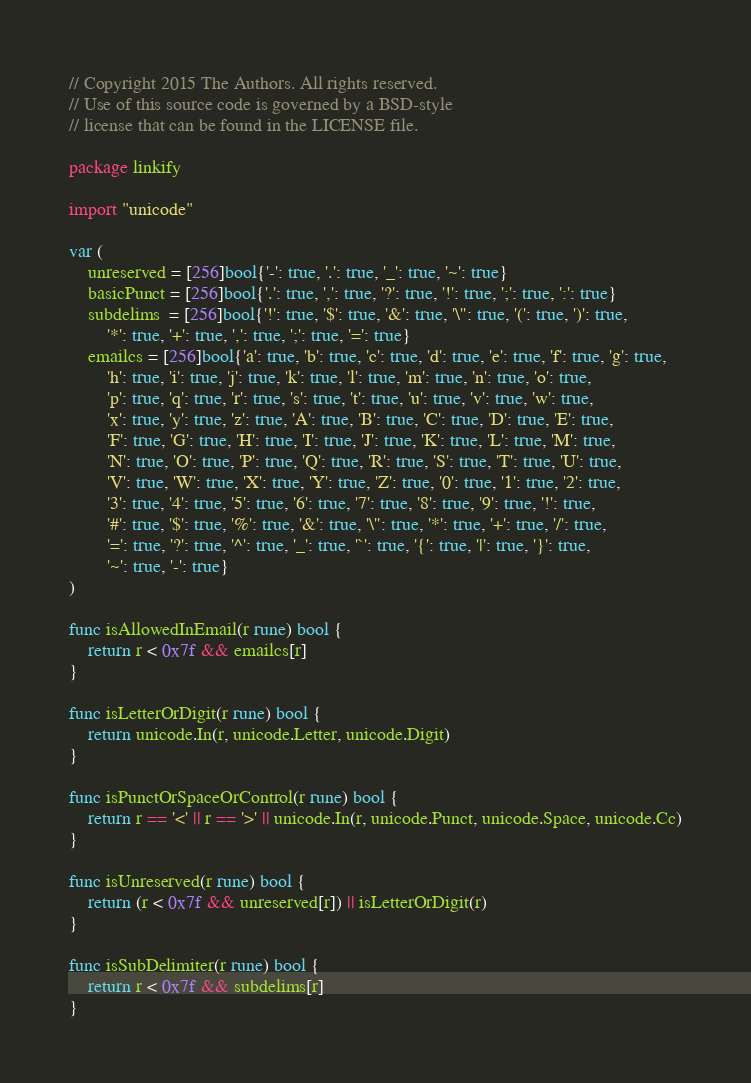Convert code to text. <code><loc_0><loc_0><loc_500><loc_500><_Go_>// Copyright 2015 The Authors. All rights reserved.
// Use of this source code is governed by a BSD-style
// license that can be found in the LICENSE file.

package linkify

import "unicode"

var (
	unreserved = [256]bool{'-': true, '.': true, '_': true, '~': true}
	basicPunct = [256]bool{'.': true, ',': true, '?': true, '!': true, ';': true, ':': true}
	subdelims  = [256]bool{'!': true, '$': true, '&': true, '\'': true, '(': true, ')': true,
		'*': true, '+': true, ',': true, ';': true, '=': true}
	emailcs = [256]bool{'a': true, 'b': true, 'c': true, 'd': true, 'e': true, 'f': true, 'g': true,
		'h': true, 'i': true, 'j': true, 'k': true, 'l': true, 'm': true, 'n': true, 'o': true,
		'p': true, 'q': true, 'r': true, 's': true, 't': true, 'u': true, 'v': true, 'w': true,
		'x': true, 'y': true, 'z': true, 'A': true, 'B': true, 'C': true, 'D': true, 'E': true,
		'F': true, 'G': true, 'H': true, 'I': true, 'J': true, 'K': true, 'L': true, 'M': true,
		'N': true, 'O': true, 'P': true, 'Q': true, 'R': true, 'S': true, 'T': true, 'U': true,
		'V': true, 'W': true, 'X': true, 'Y': true, 'Z': true, '0': true, '1': true, '2': true,
		'3': true, '4': true, '5': true, '6': true, '7': true, '8': true, '9': true, '!': true,
		'#': true, '$': true, '%': true, '&': true, '\'': true, '*': true, '+': true, '/': true,
		'=': true, '?': true, '^': true, '_': true, '`': true, '{': true, '|': true, '}': true,
		'~': true, '-': true}
)

func isAllowedInEmail(r rune) bool {
	return r < 0x7f && emailcs[r]
}

func isLetterOrDigit(r rune) bool {
	return unicode.In(r, unicode.Letter, unicode.Digit)
}

func isPunctOrSpaceOrControl(r rune) bool {
	return r == '<' || r == '>' || unicode.In(r, unicode.Punct, unicode.Space, unicode.Cc)
}

func isUnreserved(r rune) bool {
	return (r < 0x7f && unreserved[r]) || isLetterOrDigit(r)
}

func isSubDelimiter(r rune) bool {
	return r < 0x7f && subdelims[r]
}
</code> 